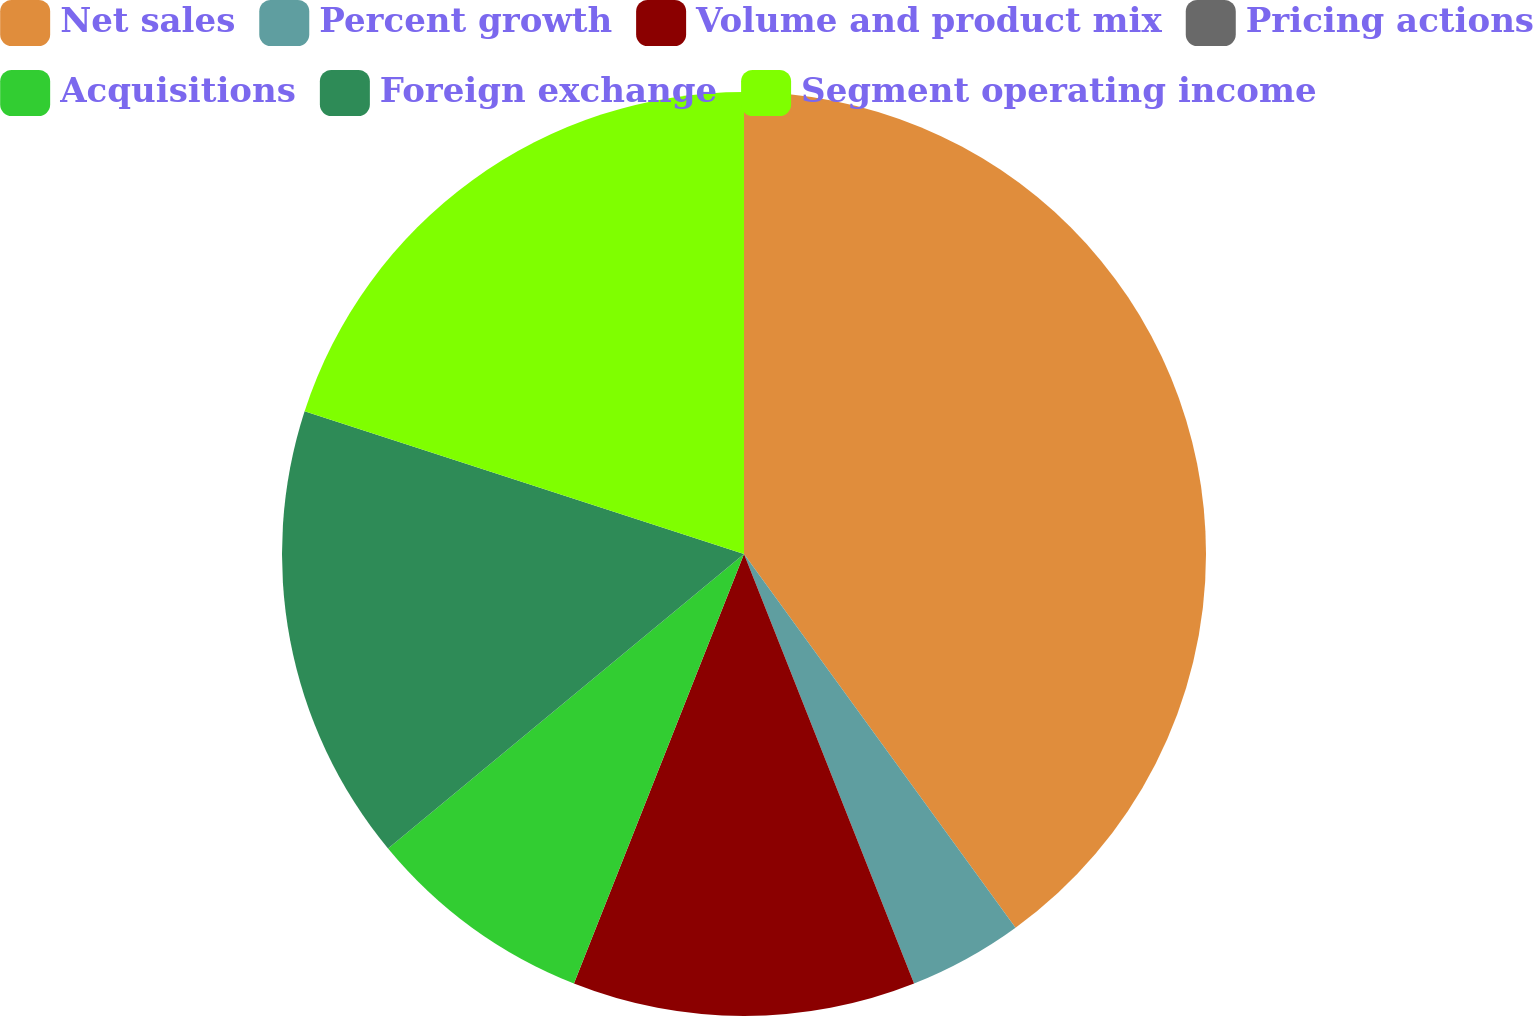Convert chart to OTSL. <chart><loc_0><loc_0><loc_500><loc_500><pie_chart><fcel>Net sales<fcel>Percent growth<fcel>Volume and product mix<fcel>Pricing actions<fcel>Acquisitions<fcel>Foreign exchange<fcel>Segment operating income<nl><fcel>40.0%<fcel>4.0%<fcel>12.0%<fcel>0.0%<fcel>8.0%<fcel>16.0%<fcel>20.0%<nl></chart> 